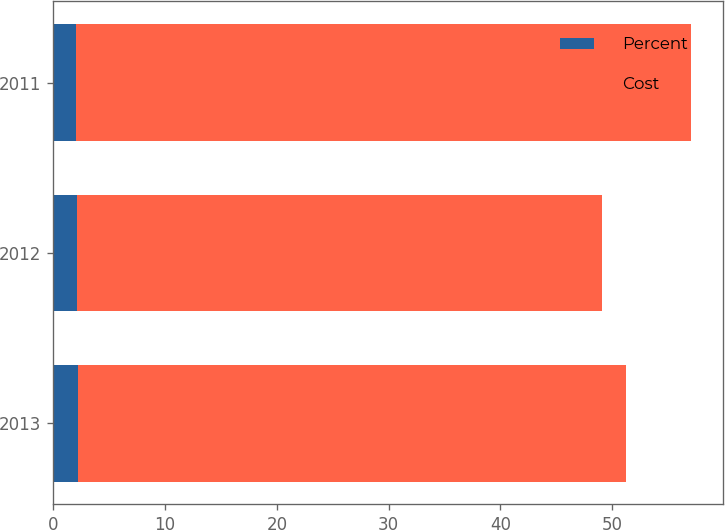Convert chart to OTSL. <chart><loc_0><loc_0><loc_500><loc_500><stacked_bar_chart><ecel><fcel>2013<fcel>2012<fcel>2011<nl><fcel>Percent<fcel>2.2<fcel>2.13<fcel>2.06<nl><fcel>Cost<fcel>49<fcel>47<fcel>55<nl></chart> 